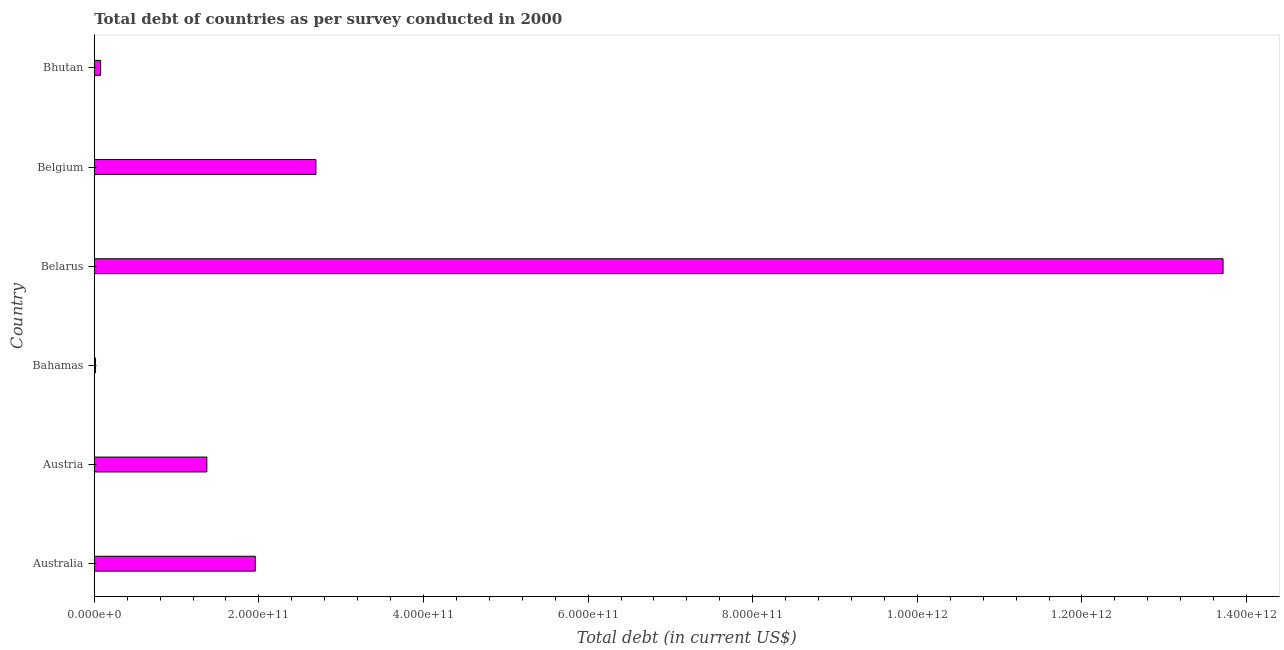Does the graph contain any zero values?
Provide a succinct answer. No. What is the title of the graph?
Offer a very short reply. Total debt of countries as per survey conducted in 2000. What is the label or title of the X-axis?
Offer a very short reply. Total debt (in current US$). What is the total debt in Bhutan?
Make the answer very short. 7.72e+09. Across all countries, what is the maximum total debt?
Offer a terse response. 1.37e+12. Across all countries, what is the minimum total debt?
Give a very brief answer. 1.51e+09. In which country was the total debt maximum?
Offer a very short reply. Belarus. In which country was the total debt minimum?
Give a very brief answer. Bahamas. What is the sum of the total debt?
Make the answer very short. 1.98e+12. What is the difference between the total debt in Austria and Belarus?
Your response must be concise. -1.23e+12. What is the average total debt per country?
Give a very brief answer. 3.30e+11. What is the median total debt?
Make the answer very short. 1.66e+11. In how many countries, is the total debt greater than 840000000000 US$?
Your answer should be very brief. 1. What is the ratio of the total debt in Austria to that in Bahamas?
Provide a short and direct response. 90.28. Is the difference between the total debt in Belarus and Bhutan greater than the difference between any two countries?
Give a very brief answer. No. What is the difference between the highest and the second highest total debt?
Your answer should be compact. 1.10e+12. Is the sum of the total debt in Belarus and Bhutan greater than the maximum total debt across all countries?
Your response must be concise. Yes. What is the difference between the highest and the lowest total debt?
Make the answer very short. 1.37e+12. How many bars are there?
Ensure brevity in your answer.  6. Are all the bars in the graph horizontal?
Provide a succinct answer. Yes. What is the difference between two consecutive major ticks on the X-axis?
Provide a short and direct response. 2.00e+11. Are the values on the major ticks of X-axis written in scientific E-notation?
Provide a succinct answer. Yes. What is the Total debt (in current US$) of Australia?
Your answer should be very brief. 1.96e+11. What is the Total debt (in current US$) of Austria?
Offer a very short reply. 1.37e+11. What is the Total debt (in current US$) of Bahamas?
Give a very brief answer. 1.51e+09. What is the Total debt (in current US$) in Belarus?
Your response must be concise. 1.37e+12. What is the Total debt (in current US$) of Belgium?
Your answer should be compact. 2.69e+11. What is the Total debt (in current US$) in Bhutan?
Ensure brevity in your answer.  7.72e+09. What is the difference between the Total debt (in current US$) in Australia and Austria?
Make the answer very short. 5.89e+1. What is the difference between the Total debt (in current US$) in Australia and Bahamas?
Keep it short and to the point. 1.94e+11. What is the difference between the Total debt (in current US$) in Australia and Belarus?
Provide a short and direct response. -1.18e+12. What is the difference between the Total debt (in current US$) in Australia and Belgium?
Your response must be concise. -7.36e+1. What is the difference between the Total debt (in current US$) in Australia and Bhutan?
Your answer should be very brief. 1.88e+11. What is the difference between the Total debt (in current US$) in Austria and Bahamas?
Make the answer very short. 1.35e+11. What is the difference between the Total debt (in current US$) in Austria and Belarus?
Your response must be concise. -1.23e+12. What is the difference between the Total debt (in current US$) in Austria and Belgium?
Keep it short and to the point. -1.33e+11. What is the difference between the Total debt (in current US$) in Austria and Bhutan?
Keep it short and to the point. 1.29e+11. What is the difference between the Total debt (in current US$) in Bahamas and Belarus?
Offer a very short reply. -1.37e+12. What is the difference between the Total debt (in current US$) in Bahamas and Belgium?
Your answer should be very brief. -2.68e+11. What is the difference between the Total debt (in current US$) in Bahamas and Bhutan?
Your answer should be very brief. -6.21e+09. What is the difference between the Total debt (in current US$) in Belarus and Belgium?
Offer a terse response. 1.10e+12. What is the difference between the Total debt (in current US$) in Belarus and Bhutan?
Your answer should be very brief. 1.36e+12. What is the difference between the Total debt (in current US$) in Belgium and Bhutan?
Make the answer very short. 2.62e+11. What is the ratio of the Total debt (in current US$) in Australia to that in Austria?
Your response must be concise. 1.43. What is the ratio of the Total debt (in current US$) in Australia to that in Bahamas?
Make the answer very short. 129.18. What is the ratio of the Total debt (in current US$) in Australia to that in Belarus?
Provide a succinct answer. 0.14. What is the ratio of the Total debt (in current US$) in Australia to that in Belgium?
Your answer should be compact. 0.73. What is the ratio of the Total debt (in current US$) in Australia to that in Bhutan?
Your answer should be very brief. 25.34. What is the ratio of the Total debt (in current US$) in Austria to that in Bahamas?
Provide a succinct answer. 90.28. What is the ratio of the Total debt (in current US$) in Austria to that in Belgium?
Your response must be concise. 0.51. What is the ratio of the Total debt (in current US$) in Austria to that in Bhutan?
Give a very brief answer. 17.71. What is the ratio of the Total debt (in current US$) in Bahamas to that in Belarus?
Make the answer very short. 0. What is the ratio of the Total debt (in current US$) in Bahamas to that in Belgium?
Make the answer very short. 0.01. What is the ratio of the Total debt (in current US$) in Bahamas to that in Bhutan?
Offer a terse response. 0.2. What is the ratio of the Total debt (in current US$) in Belarus to that in Belgium?
Give a very brief answer. 5.09. What is the ratio of the Total debt (in current US$) in Belarus to that in Bhutan?
Your answer should be compact. 177.6. What is the ratio of the Total debt (in current US$) in Belgium to that in Bhutan?
Make the answer very short. 34.87. 